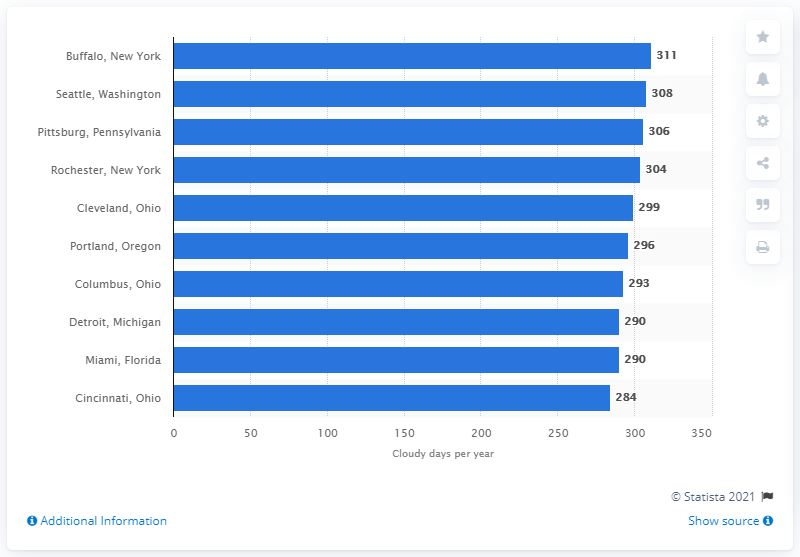How many days of cloud cover did Buffalo have in 2011? The image shows a bar graph listing various cities along with the number of cloudy days per year. According to the bar associated with Buffalo, New York, it experienced 311 cloudy days per year. The data might refer to an average, not specifically to the year 2011. For the most accurate numbers for a particular year, consulting historical weather data for Buffalo in 2011 would be more precise. 